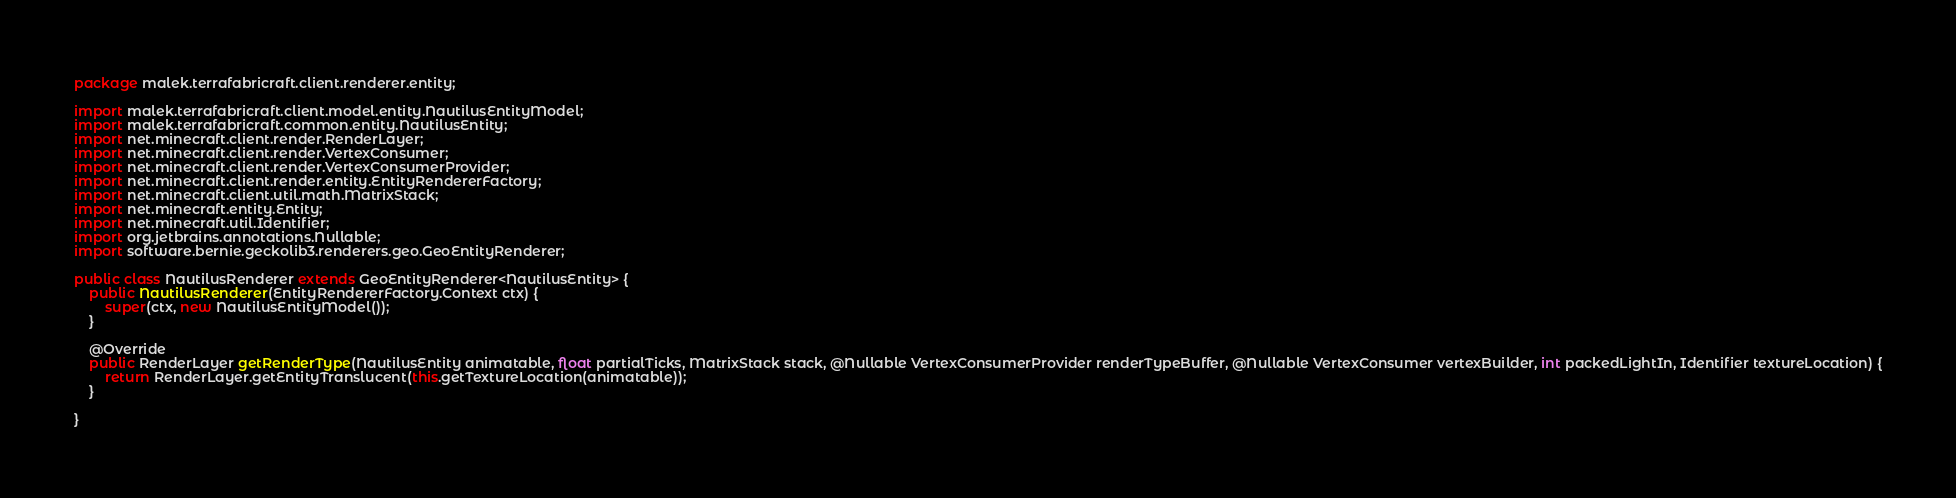Convert code to text. <code><loc_0><loc_0><loc_500><loc_500><_Java_>package malek.terrafabricraft.client.renderer.entity;

import malek.terrafabricraft.client.model.entity.NautilusEntityModel;
import malek.terrafabricraft.common.entity.NautilusEntity;
import net.minecraft.client.render.RenderLayer;
import net.minecraft.client.render.VertexConsumer;
import net.minecraft.client.render.VertexConsumerProvider;
import net.minecraft.client.render.entity.EntityRendererFactory;
import net.minecraft.client.util.math.MatrixStack;
import net.minecraft.entity.Entity;
import net.minecraft.util.Identifier;
import org.jetbrains.annotations.Nullable;
import software.bernie.geckolib3.renderers.geo.GeoEntityRenderer;

public class NautilusRenderer extends GeoEntityRenderer<NautilusEntity> {
    public NautilusRenderer(EntityRendererFactory.Context ctx) {
        super(ctx, new NautilusEntityModel());
    }

    @Override
    public RenderLayer getRenderType(NautilusEntity animatable, float partialTicks, MatrixStack stack, @Nullable VertexConsumerProvider renderTypeBuffer, @Nullable VertexConsumer vertexBuilder, int packedLightIn, Identifier textureLocation) {
        return RenderLayer.getEntityTranslucent(this.getTextureLocation(animatable));
    }

}</code> 